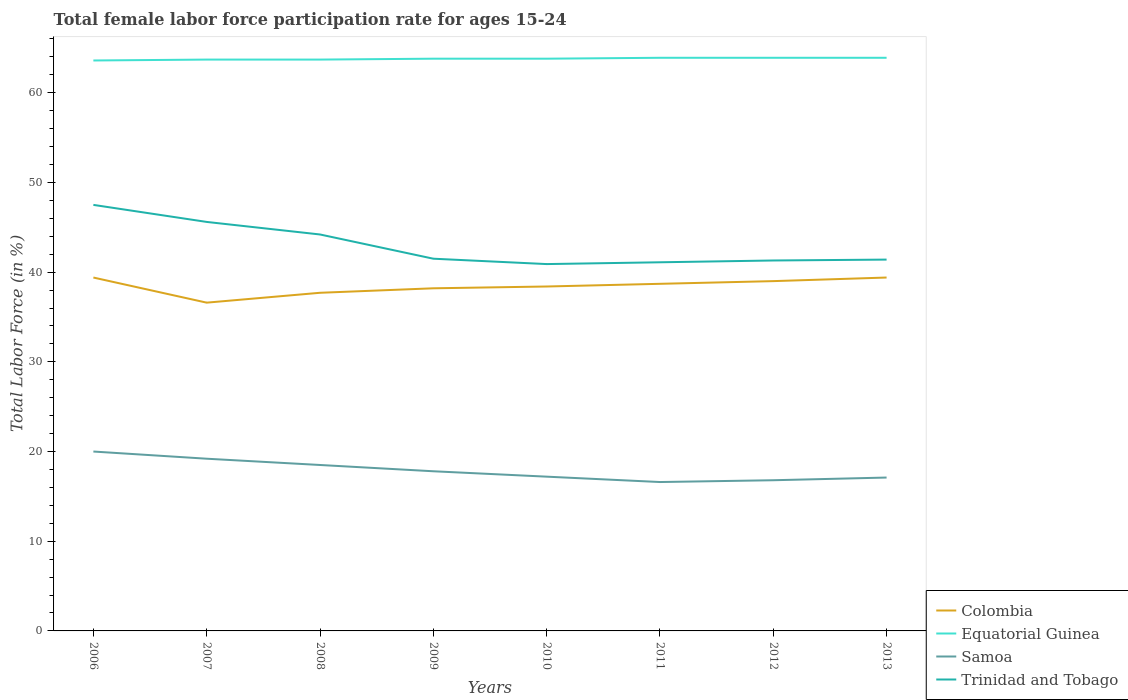How many different coloured lines are there?
Offer a terse response. 4. Across all years, what is the maximum female labor force participation rate in Colombia?
Give a very brief answer. 36.6. In which year was the female labor force participation rate in Equatorial Guinea maximum?
Ensure brevity in your answer.  2006. What is the total female labor force participation rate in Equatorial Guinea in the graph?
Offer a terse response. -0.1. What is the difference between the highest and the second highest female labor force participation rate in Colombia?
Ensure brevity in your answer.  2.8. How many lines are there?
Ensure brevity in your answer.  4. How many years are there in the graph?
Provide a succinct answer. 8. Are the values on the major ticks of Y-axis written in scientific E-notation?
Offer a terse response. No. What is the title of the graph?
Make the answer very short. Total female labor force participation rate for ages 15-24. What is the label or title of the X-axis?
Your response must be concise. Years. What is the label or title of the Y-axis?
Offer a terse response. Total Labor Force (in %). What is the Total Labor Force (in %) in Colombia in 2006?
Make the answer very short. 39.4. What is the Total Labor Force (in %) in Equatorial Guinea in 2006?
Your answer should be compact. 63.6. What is the Total Labor Force (in %) of Samoa in 2006?
Provide a short and direct response. 20. What is the Total Labor Force (in %) in Trinidad and Tobago in 2006?
Ensure brevity in your answer.  47.5. What is the Total Labor Force (in %) of Colombia in 2007?
Ensure brevity in your answer.  36.6. What is the Total Labor Force (in %) in Equatorial Guinea in 2007?
Make the answer very short. 63.7. What is the Total Labor Force (in %) of Samoa in 2007?
Offer a very short reply. 19.2. What is the Total Labor Force (in %) in Trinidad and Tobago in 2007?
Keep it short and to the point. 45.6. What is the Total Labor Force (in %) in Colombia in 2008?
Ensure brevity in your answer.  37.7. What is the Total Labor Force (in %) in Equatorial Guinea in 2008?
Provide a short and direct response. 63.7. What is the Total Labor Force (in %) in Trinidad and Tobago in 2008?
Ensure brevity in your answer.  44.2. What is the Total Labor Force (in %) of Colombia in 2009?
Ensure brevity in your answer.  38.2. What is the Total Labor Force (in %) in Equatorial Guinea in 2009?
Your answer should be compact. 63.8. What is the Total Labor Force (in %) in Samoa in 2009?
Your answer should be very brief. 17.8. What is the Total Labor Force (in %) of Trinidad and Tobago in 2009?
Offer a very short reply. 41.5. What is the Total Labor Force (in %) in Colombia in 2010?
Your answer should be very brief. 38.4. What is the Total Labor Force (in %) of Equatorial Guinea in 2010?
Offer a terse response. 63.8. What is the Total Labor Force (in %) of Samoa in 2010?
Provide a succinct answer. 17.2. What is the Total Labor Force (in %) in Trinidad and Tobago in 2010?
Offer a very short reply. 40.9. What is the Total Labor Force (in %) of Colombia in 2011?
Make the answer very short. 38.7. What is the Total Labor Force (in %) of Equatorial Guinea in 2011?
Offer a terse response. 63.9. What is the Total Labor Force (in %) in Samoa in 2011?
Provide a short and direct response. 16.6. What is the Total Labor Force (in %) of Trinidad and Tobago in 2011?
Ensure brevity in your answer.  41.1. What is the Total Labor Force (in %) of Equatorial Guinea in 2012?
Your answer should be compact. 63.9. What is the Total Labor Force (in %) in Samoa in 2012?
Your answer should be very brief. 16.8. What is the Total Labor Force (in %) in Trinidad and Tobago in 2012?
Your answer should be compact. 41.3. What is the Total Labor Force (in %) in Colombia in 2013?
Keep it short and to the point. 39.4. What is the Total Labor Force (in %) of Equatorial Guinea in 2013?
Give a very brief answer. 63.9. What is the Total Labor Force (in %) in Samoa in 2013?
Make the answer very short. 17.1. What is the Total Labor Force (in %) of Trinidad and Tobago in 2013?
Ensure brevity in your answer.  41.4. Across all years, what is the maximum Total Labor Force (in %) of Colombia?
Give a very brief answer. 39.4. Across all years, what is the maximum Total Labor Force (in %) in Equatorial Guinea?
Offer a very short reply. 63.9. Across all years, what is the maximum Total Labor Force (in %) of Samoa?
Give a very brief answer. 20. Across all years, what is the maximum Total Labor Force (in %) of Trinidad and Tobago?
Offer a terse response. 47.5. Across all years, what is the minimum Total Labor Force (in %) in Colombia?
Your response must be concise. 36.6. Across all years, what is the minimum Total Labor Force (in %) of Equatorial Guinea?
Give a very brief answer. 63.6. Across all years, what is the minimum Total Labor Force (in %) in Samoa?
Keep it short and to the point. 16.6. Across all years, what is the minimum Total Labor Force (in %) of Trinidad and Tobago?
Offer a terse response. 40.9. What is the total Total Labor Force (in %) in Colombia in the graph?
Your answer should be compact. 307.4. What is the total Total Labor Force (in %) in Equatorial Guinea in the graph?
Keep it short and to the point. 510.3. What is the total Total Labor Force (in %) in Samoa in the graph?
Ensure brevity in your answer.  143.2. What is the total Total Labor Force (in %) in Trinidad and Tobago in the graph?
Make the answer very short. 343.5. What is the difference between the Total Labor Force (in %) of Colombia in 2006 and that in 2007?
Make the answer very short. 2.8. What is the difference between the Total Labor Force (in %) of Trinidad and Tobago in 2006 and that in 2007?
Give a very brief answer. 1.9. What is the difference between the Total Labor Force (in %) of Colombia in 2006 and that in 2008?
Make the answer very short. 1.7. What is the difference between the Total Labor Force (in %) of Samoa in 2006 and that in 2008?
Give a very brief answer. 1.5. What is the difference between the Total Labor Force (in %) of Colombia in 2006 and that in 2009?
Provide a short and direct response. 1.2. What is the difference between the Total Labor Force (in %) in Equatorial Guinea in 2006 and that in 2009?
Offer a terse response. -0.2. What is the difference between the Total Labor Force (in %) of Colombia in 2006 and that in 2010?
Make the answer very short. 1. What is the difference between the Total Labor Force (in %) of Equatorial Guinea in 2006 and that in 2010?
Offer a very short reply. -0.2. What is the difference between the Total Labor Force (in %) of Samoa in 2006 and that in 2010?
Give a very brief answer. 2.8. What is the difference between the Total Labor Force (in %) in Trinidad and Tobago in 2006 and that in 2010?
Give a very brief answer. 6.6. What is the difference between the Total Labor Force (in %) in Colombia in 2006 and that in 2011?
Offer a terse response. 0.7. What is the difference between the Total Labor Force (in %) in Equatorial Guinea in 2006 and that in 2011?
Provide a short and direct response. -0.3. What is the difference between the Total Labor Force (in %) of Colombia in 2006 and that in 2012?
Provide a short and direct response. 0.4. What is the difference between the Total Labor Force (in %) of Samoa in 2006 and that in 2012?
Your answer should be very brief. 3.2. What is the difference between the Total Labor Force (in %) of Trinidad and Tobago in 2006 and that in 2012?
Your answer should be compact. 6.2. What is the difference between the Total Labor Force (in %) of Equatorial Guinea in 2006 and that in 2013?
Your answer should be very brief. -0.3. What is the difference between the Total Labor Force (in %) of Colombia in 2007 and that in 2008?
Your answer should be very brief. -1.1. What is the difference between the Total Labor Force (in %) in Trinidad and Tobago in 2007 and that in 2008?
Offer a very short reply. 1.4. What is the difference between the Total Labor Force (in %) of Colombia in 2007 and that in 2009?
Your response must be concise. -1.6. What is the difference between the Total Labor Force (in %) of Samoa in 2007 and that in 2009?
Provide a succinct answer. 1.4. What is the difference between the Total Labor Force (in %) in Colombia in 2007 and that in 2010?
Ensure brevity in your answer.  -1.8. What is the difference between the Total Labor Force (in %) in Equatorial Guinea in 2007 and that in 2010?
Keep it short and to the point. -0.1. What is the difference between the Total Labor Force (in %) in Trinidad and Tobago in 2007 and that in 2011?
Your answer should be compact. 4.5. What is the difference between the Total Labor Force (in %) in Colombia in 2007 and that in 2012?
Ensure brevity in your answer.  -2.4. What is the difference between the Total Labor Force (in %) in Equatorial Guinea in 2007 and that in 2012?
Your answer should be very brief. -0.2. What is the difference between the Total Labor Force (in %) of Samoa in 2007 and that in 2012?
Keep it short and to the point. 2.4. What is the difference between the Total Labor Force (in %) of Trinidad and Tobago in 2007 and that in 2012?
Provide a short and direct response. 4.3. What is the difference between the Total Labor Force (in %) in Colombia in 2007 and that in 2013?
Keep it short and to the point. -2.8. What is the difference between the Total Labor Force (in %) in Trinidad and Tobago in 2007 and that in 2013?
Your response must be concise. 4.2. What is the difference between the Total Labor Force (in %) in Equatorial Guinea in 2008 and that in 2009?
Your response must be concise. -0.1. What is the difference between the Total Labor Force (in %) of Equatorial Guinea in 2008 and that in 2010?
Your answer should be compact. -0.1. What is the difference between the Total Labor Force (in %) of Samoa in 2008 and that in 2010?
Your response must be concise. 1.3. What is the difference between the Total Labor Force (in %) in Trinidad and Tobago in 2008 and that in 2010?
Provide a succinct answer. 3.3. What is the difference between the Total Labor Force (in %) of Trinidad and Tobago in 2008 and that in 2011?
Ensure brevity in your answer.  3.1. What is the difference between the Total Labor Force (in %) of Equatorial Guinea in 2008 and that in 2012?
Offer a terse response. -0.2. What is the difference between the Total Labor Force (in %) in Trinidad and Tobago in 2008 and that in 2012?
Provide a succinct answer. 2.9. What is the difference between the Total Labor Force (in %) in Colombia in 2008 and that in 2013?
Offer a very short reply. -1.7. What is the difference between the Total Labor Force (in %) in Equatorial Guinea in 2009 and that in 2010?
Ensure brevity in your answer.  0. What is the difference between the Total Labor Force (in %) of Colombia in 2009 and that in 2011?
Give a very brief answer. -0.5. What is the difference between the Total Labor Force (in %) of Equatorial Guinea in 2009 and that in 2011?
Provide a short and direct response. -0.1. What is the difference between the Total Labor Force (in %) in Equatorial Guinea in 2009 and that in 2012?
Keep it short and to the point. -0.1. What is the difference between the Total Labor Force (in %) of Samoa in 2009 and that in 2012?
Your answer should be compact. 1. What is the difference between the Total Labor Force (in %) in Trinidad and Tobago in 2009 and that in 2012?
Provide a succinct answer. 0.2. What is the difference between the Total Labor Force (in %) of Equatorial Guinea in 2009 and that in 2013?
Your response must be concise. -0.1. What is the difference between the Total Labor Force (in %) in Trinidad and Tobago in 2009 and that in 2013?
Your answer should be compact. 0.1. What is the difference between the Total Labor Force (in %) in Colombia in 2010 and that in 2011?
Your answer should be compact. -0.3. What is the difference between the Total Labor Force (in %) of Trinidad and Tobago in 2010 and that in 2011?
Make the answer very short. -0.2. What is the difference between the Total Labor Force (in %) of Colombia in 2010 and that in 2012?
Offer a very short reply. -0.6. What is the difference between the Total Labor Force (in %) of Equatorial Guinea in 2010 and that in 2012?
Offer a very short reply. -0.1. What is the difference between the Total Labor Force (in %) of Trinidad and Tobago in 2010 and that in 2012?
Give a very brief answer. -0.4. What is the difference between the Total Labor Force (in %) in Equatorial Guinea in 2010 and that in 2013?
Your answer should be compact. -0.1. What is the difference between the Total Labor Force (in %) in Samoa in 2010 and that in 2013?
Keep it short and to the point. 0.1. What is the difference between the Total Labor Force (in %) in Trinidad and Tobago in 2010 and that in 2013?
Your answer should be compact. -0.5. What is the difference between the Total Labor Force (in %) in Equatorial Guinea in 2011 and that in 2012?
Give a very brief answer. 0. What is the difference between the Total Labor Force (in %) of Samoa in 2011 and that in 2012?
Your answer should be compact. -0.2. What is the difference between the Total Labor Force (in %) of Trinidad and Tobago in 2011 and that in 2012?
Make the answer very short. -0.2. What is the difference between the Total Labor Force (in %) in Colombia in 2011 and that in 2013?
Ensure brevity in your answer.  -0.7. What is the difference between the Total Labor Force (in %) in Samoa in 2011 and that in 2013?
Your response must be concise. -0.5. What is the difference between the Total Labor Force (in %) of Trinidad and Tobago in 2011 and that in 2013?
Your answer should be compact. -0.3. What is the difference between the Total Labor Force (in %) of Colombia in 2012 and that in 2013?
Ensure brevity in your answer.  -0.4. What is the difference between the Total Labor Force (in %) in Equatorial Guinea in 2012 and that in 2013?
Give a very brief answer. 0. What is the difference between the Total Labor Force (in %) of Samoa in 2012 and that in 2013?
Give a very brief answer. -0.3. What is the difference between the Total Labor Force (in %) in Trinidad and Tobago in 2012 and that in 2013?
Make the answer very short. -0.1. What is the difference between the Total Labor Force (in %) in Colombia in 2006 and the Total Labor Force (in %) in Equatorial Guinea in 2007?
Keep it short and to the point. -24.3. What is the difference between the Total Labor Force (in %) of Colombia in 2006 and the Total Labor Force (in %) of Samoa in 2007?
Ensure brevity in your answer.  20.2. What is the difference between the Total Labor Force (in %) of Equatorial Guinea in 2006 and the Total Labor Force (in %) of Samoa in 2007?
Offer a terse response. 44.4. What is the difference between the Total Labor Force (in %) of Equatorial Guinea in 2006 and the Total Labor Force (in %) of Trinidad and Tobago in 2007?
Offer a terse response. 18. What is the difference between the Total Labor Force (in %) in Samoa in 2006 and the Total Labor Force (in %) in Trinidad and Tobago in 2007?
Ensure brevity in your answer.  -25.6. What is the difference between the Total Labor Force (in %) in Colombia in 2006 and the Total Labor Force (in %) in Equatorial Guinea in 2008?
Give a very brief answer. -24.3. What is the difference between the Total Labor Force (in %) in Colombia in 2006 and the Total Labor Force (in %) in Samoa in 2008?
Keep it short and to the point. 20.9. What is the difference between the Total Labor Force (in %) in Colombia in 2006 and the Total Labor Force (in %) in Trinidad and Tobago in 2008?
Your answer should be compact. -4.8. What is the difference between the Total Labor Force (in %) of Equatorial Guinea in 2006 and the Total Labor Force (in %) of Samoa in 2008?
Offer a very short reply. 45.1. What is the difference between the Total Labor Force (in %) in Equatorial Guinea in 2006 and the Total Labor Force (in %) in Trinidad and Tobago in 2008?
Keep it short and to the point. 19.4. What is the difference between the Total Labor Force (in %) in Samoa in 2006 and the Total Labor Force (in %) in Trinidad and Tobago in 2008?
Provide a short and direct response. -24.2. What is the difference between the Total Labor Force (in %) of Colombia in 2006 and the Total Labor Force (in %) of Equatorial Guinea in 2009?
Your answer should be very brief. -24.4. What is the difference between the Total Labor Force (in %) of Colombia in 2006 and the Total Labor Force (in %) of Samoa in 2009?
Offer a very short reply. 21.6. What is the difference between the Total Labor Force (in %) of Colombia in 2006 and the Total Labor Force (in %) of Trinidad and Tobago in 2009?
Provide a succinct answer. -2.1. What is the difference between the Total Labor Force (in %) of Equatorial Guinea in 2006 and the Total Labor Force (in %) of Samoa in 2009?
Provide a short and direct response. 45.8. What is the difference between the Total Labor Force (in %) of Equatorial Guinea in 2006 and the Total Labor Force (in %) of Trinidad and Tobago in 2009?
Provide a short and direct response. 22.1. What is the difference between the Total Labor Force (in %) of Samoa in 2006 and the Total Labor Force (in %) of Trinidad and Tobago in 2009?
Your answer should be very brief. -21.5. What is the difference between the Total Labor Force (in %) of Colombia in 2006 and the Total Labor Force (in %) of Equatorial Guinea in 2010?
Ensure brevity in your answer.  -24.4. What is the difference between the Total Labor Force (in %) in Equatorial Guinea in 2006 and the Total Labor Force (in %) in Samoa in 2010?
Keep it short and to the point. 46.4. What is the difference between the Total Labor Force (in %) of Equatorial Guinea in 2006 and the Total Labor Force (in %) of Trinidad and Tobago in 2010?
Keep it short and to the point. 22.7. What is the difference between the Total Labor Force (in %) in Samoa in 2006 and the Total Labor Force (in %) in Trinidad and Tobago in 2010?
Offer a very short reply. -20.9. What is the difference between the Total Labor Force (in %) of Colombia in 2006 and the Total Labor Force (in %) of Equatorial Guinea in 2011?
Provide a short and direct response. -24.5. What is the difference between the Total Labor Force (in %) in Colombia in 2006 and the Total Labor Force (in %) in Samoa in 2011?
Offer a very short reply. 22.8. What is the difference between the Total Labor Force (in %) of Colombia in 2006 and the Total Labor Force (in %) of Trinidad and Tobago in 2011?
Offer a terse response. -1.7. What is the difference between the Total Labor Force (in %) of Equatorial Guinea in 2006 and the Total Labor Force (in %) of Samoa in 2011?
Ensure brevity in your answer.  47. What is the difference between the Total Labor Force (in %) in Samoa in 2006 and the Total Labor Force (in %) in Trinidad and Tobago in 2011?
Provide a short and direct response. -21.1. What is the difference between the Total Labor Force (in %) in Colombia in 2006 and the Total Labor Force (in %) in Equatorial Guinea in 2012?
Give a very brief answer. -24.5. What is the difference between the Total Labor Force (in %) of Colombia in 2006 and the Total Labor Force (in %) of Samoa in 2012?
Keep it short and to the point. 22.6. What is the difference between the Total Labor Force (in %) in Equatorial Guinea in 2006 and the Total Labor Force (in %) in Samoa in 2012?
Provide a short and direct response. 46.8. What is the difference between the Total Labor Force (in %) of Equatorial Guinea in 2006 and the Total Labor Force (in %) of Trinidad and Tobago in 2012?
Your response must be concise. 22.3. What is the difference between the Total Labor Force (in %) of Samoa in 2006 and the Total Labor Force (in %) of Trinidad and Tobago in 2012?
Your answer should be compact. -21.3. What is the difference between the Total Labor Force (in %) in Colombia in 2006 and the Total Labor Force (in %) in Equatorial Guinea in 2013?
Give a very brief answer. -24.5. What is the difference between the Total Labor Force (in %) in Colombia in 2006 and the Total Labor Force (in %) in Samoa in 2013?
Make the answer very short. 22.3. What is the difference between the Total Labor Force (in %) in Colombia in 2006 and the Total Labor Force (in %) in Trinidad and Tobago in 2013?
Your answer should be very brief. -2. What is the difference between the Total Labor Force (in %) in Equatorial Guinea in 2006 and the Total Labor Force (in %) in Samoa in 2013?
Your answer should be very brief. 46.5. What is the difference between the Total Labor Force (in %) in Equatorial Guinea in 2006 and the Total Labor Force (in %) in Trinidad and Tobago in 2013?
Offer a very short reply. 22.2. What is the difference between the Total Labor Force (in %) in Samoa in 2006 and the Total Labor Force (in %) in Trinidad and Tobago in 2013?
Offer a terse response. -21.4. What is the difference between the Total Labor Force (in %) in Colombia in 2007 and the Total Labor Force (in %) in Equatorial Guinea in 2008?
Offer a very short reply. -27.1. What is the difference between the Total Labor Force (in %) of Colombia in 2007 and the Total Labor Force (in %) of Samoa in 2008?
Make the answer very short. 18.1. What is the difference between the Total Labor Force (in %) of Colombia in 2007 and the Total Labor Force (in %) of Trinidad and Tobago in 2008?
Your answer should be very brief. -7.6. What is the difference between the Total Labor Force (in %) of Equatorial Guinea in 2007 and the Total Labor Force (in %) of Samoa in 2008?
Keep it short and to the point. 45.2. What is the difference between the Total Labor Force (in %) of Equatorial Guinea in 2007 and the Total Labor Force (in %) of Trinidad and Tobago in 2008?
Provide a succinct answer. 19.5. What is the difference between the Total Labor Force (in %) of Colombia in 2007 and the Total Labor Force (in %) of Equatorial Guinea in 2009?
Offer a terse response. -27.2. What is the difference between the Total Labor Force (in %) in Equatorial Guinea in 2007 and the Total Labor Force (in %) in Samoa in 2009?
Ensure brevity in your answer.  45.9. What is the difference between the Total Labor Force (in %) of Samoa in 2007 and the Total Labor Force (in %) of Trinidad and Tobago in 2009?
Your answer should be very brief. -22.3. What is the difference between the Total Labor Force (in %) in Colombia in 2007 and the Total Labor Force (in %) in Equatorial Guinea in 2010?
Your response must be concise. -27.2. What is the difference between the Total Labor Force (in %) of Equatorial Guinea in 2007 and the Total Labor Force (in %) of Samoa in 2010?
Your response must be concise. 46.5. What is the difference between the Total Labor Force (in %) in Equatorial Guinea in 2007 and the Total Labor Force (in %) in Trinidad and Tobago in 2010?
Offer a terse response. 22.8. What is the difference between the Total Labor Force (in %) in Samoa in 2007 and the Total Labor Force (in %) in Trinidad and Tobago in 2010?
Your answer should be very brief. -21.7. What is the difference between the Total Labor Force (in %) in Colombia in 2007 and the Total Labor Force (in %) in Equatorial Guinea in 2011?
Offer a terse response. -27.3. What is the difference between the Total Labor Force (in %) in Colombia in 2007 and the Total Labor Force (in %) in Samoa in 2011?
Offer a very short reply. 20. What is the difference between the Total Labor Force (in %) in Colombia in 2007 and the Total Labor Force (in %) in Trinidad and Tobago in 2011?
Offer a terse response. -4.5. What is the difference between the Total Labor Force (in %) of Equatorial Guinea in 2007 and the Total Labor Force (in %) of Samoa in 2011?
Make the answer very short. 47.1. What is the difference between the Total Labor Force (in %) in Equatorial Guinea in 2007 and the Total Labor Force (in %) in Trinidad and Tobago in 2011?
Your answer should be very brief. 22.6. What is the difference between the Total Labor Force (in %) of Samoa in 2007 and the Total Labor Force (in %) of Trinidad and Tobago in 2011?
Offer a very short reply. -21.9. What is the difference between the Total Labor Force (in %) in Colombia in 2007 and the Total Labor Force (in %) in Equatorial Guinea in 2012?
Provide a succinct answer. -27.3. What is the difference between the Total Labor Force (in %) of Colombia in 2007 and the Total Labor Force (in %) of Samoa in 2012?
Your answer should be compact. 19.8. What is the difference between the Total Labor Force (in %) of Equatorial Guinea in 2007 and the Total Labor Force (in %) of Samoa in 2012?
Your answer should be very brief. 46.9. What is the difference between the Total Labor Force (in %) in Equatorial Guinea in 2007 and the Total Labor Force (in %) in Trinidad and Tobago in 2012?
Your answer should be compact. 22.4. What is the difference between the Total Labor Force (in %) of Samoa in 2007 and the Total Labor Force (in %) of Trinidad and Tobago in 2012?
Your answer should be very brief. -22.1. What is the difference between the Total Labor Force (in %) of Colombia in 2007 and the Total Labor Force (in %) of Equatorial Guinea in 2013?
Offer a terse response. -27.3. What is the difference between the Total Labor Force (in %) in Colombia in 2007 and the Total Labor Force (in %) in Trinidad and Tobago in 2013?
Offer a very short reply. -4.8. What is the difference between the Total Labor Force (in %) of Equatorial Guinea in 2007 and the Total Labor Force (in %) of Samoa in 2013?
Make the answer very short. 46.6. What is the difference between the Total Labor Force (in %) in Equatorial Guinea in 2007 and the Total Labor Force (in %) in Trinidad and Tobago in 2013?
Ensure brevity in your answer.  22.3. What is the difference between the Total Labor Force (in %) in Samoa in 2007 and the Total Labor Force (in %) in Trinidad and Tobago in 2013?
Keep it short and to the point. -22.2. What is the difference between the Total Labor Force (in %) of Colombia in 2008 and the Total Labor Force (in %) of Equatorial Guinea in 2009?
Make the answer very short. -26.1. What is the difference between the Total Labor Force (in %) of Equatorial Guinea in 2008 and the Total Labor Force (in %) of Samoa in 2009?
Your answer should be compact. 45.9. What is the difference between the Total Labor Force (in %) of Equatorial Guinea in 2008 and the Total Labor Force (in %) of Trinidad and Tobago in 2009?
Offer a terse response. 22.2. What is the difference between the Total Labor Force (in %) of Samoa in 2008 and the Total Labor Force (in %) of Trinidad and Tobago in 2009?
Offer a terse response. -23. What is the difference between the Total Labor Force (in %) in Colombia in 2008 and the Total Labor Force (in %) in Equatorial Guinea in 2010?
Offer a terse response. -26.1. What is the difference between the Total Labor Force (in %) in Colombia in 2008 and the Total Labor Force (in %) in Samoa in 2010?
Your answer should be compact. 20.5. What is the difference between the Total Labor Force (in %) in Colombia in 2008 and the Total Labor Force (in %) in Trinidad and Tobago in 2010?
Provide a succinct answer. -3.2. What is the difference between the Total Labor Force (in %) of Equatorial Guinea in 2008 and the Total Labor Force (in %) of Samoa in 2010?
Offer a terse response. 46.5. What is the difference between the Total Labor Force (in %) of Equatorial Guinea in 2008 and the Total Labor Force (in %) of Trinidad and Tobago in 2010?
Offer a very short reply. 22.8. What is the difference between the Total Labor Force (in %) in Samoa in 2008 and the Total Labor Force (in %) in Trinidad and Tobago in 2010?
Your answer should be very brief. -22.4. What is the difference between the Total Labor Force (in %) of Colombia in 2008 and the Total Labor Force (in %) of Equatorial Guinea in 2011?
Ensure brevity in your answer.  -26.2. What is the difference between the Total Labor Force (in %) of Colombia in 2008 and the Total Labor Force (in %) of Samoa in 2011?
Your answer should be compact. 21.1. What is the difference between the Total Labor Force (in %) of Equatorial Guinea in 2008 and the Total Labor Force (in %) of Samoa in 2011?
Ensure brevity in your answer.  47.1. What is the difference between the Total Labor Force (in %) of Equatorial Guinea in 2008 and the Total Labor Force (in %) of Trinidad and Tobago in 2011?
Provide a succinct answer. 22.6. What is the difference between the Total Labor Force (in %) of Samoa in 2008 and the Total Labor Force (in %) of Trinidad and Tobago in 2011?
Your response must be concise. -22.6. What is the difference between the Total Labor Force (in %) of Colombia in 2008 and the Total Labor Force (in %) of Equatorial Guinea in 2012?
Your answer should be compact. -26.2. What is the difference between the Total Labor Force (in %) in Colombia in 2008 and the Total Labor Force (in %) in Samoa in 2012?
Keep it short and to the point. 20.9. What is the difference between the Total Labor Force (in %) of Equatorial Guinea in 2008 and the Total Labor Force (in %) of Samoa in 2012?
Offer a terse response. 46.9. What is the difference between the Total Labor Force (in %) of Equatorial Guinea in 2008 and the Total Labor Force (in %) of Trinidad and Tobago in 2012?
Your answer should be compact. 22.4. What is the difference between the Total Labor Force (in %) in Samoa in 2008 and the Total Labor Force (in %) in Trinidad and Tobago in 2012?
Your answer should be very brief. -22.8. What is the difference between the Total Labor Force (in %) in Colombia in 2008 and the Total Labor Force (in %) in Equatorial Guinea in 2013?
Offer a terse response. -26.2. What is the difference between the Total Labor Force (in %) of Colombia in 2008 and the Total Labor Force (in %) of Samoa in 2013?
Provide a short and direct response. 20.6. What is the difference between the Total Labor Force (in %) in Colombia in 2008 and the Total Labor Force (in %) in Trinidad and Tobago in 2013?
Your answer should be compact. -3.7. What is the difference between the Total Labor Force (in %) in Equatorial Guinea in 2008 and the Total Labor Force (in %) in Samoa in 2013?
Your answer should be compact. 46.6. What is the difference between the Total Labor Force (in %) of Equatorial Guinea in 2008 and the Total Labor Force (in %) of Trinidad and Tobago in 2013?
Your answer should be compact. 22.3. What is the difference between the Total Labor Force (in %) in Samoa in 2008 and the Total Labor Force (in %) in Trinidad and Tobago in 2013?
Provide a short and direct response. -22.9. What is the difference between the Total Labor Force (in %) of Colombia in 2009 and the Total Labor Force (in %) of Equatorial Guinea in 2010?
Provide a succinct answer. -25.6. What is the difference between the Total Labor Force (in %) in Colombia in 2009 and the Total Labor Force (in %) in Samoa in 2010?
Your answer should be compact. 21. What is the difference between the Total Labor Force (in %) of Equatorial Guinea in 2009 and the Total Labor Force (in %) of Samoa in 2010?
Offer a terse response. 46.6. What is the difference between the Total Labor Force (in %) in Equatorial Guinea in 2009 and the Total Labor Force (in %) in Trinidad and Tobago in 2010?
Offer a terse response. 22.9. What is the difference between the Total Labor Force (in %) of Samoa in 2009 and the Total Labor Force (in %) of Trinidad and Tobago in 2010?
Your answer should be very brief. -23.1. What is the difference between the Total Labor Force (in %) of Colombia in 2009 and the Total Labor Force (in %) of Equatorial Guinea in 2011?
Offer a terse response. -25.7. What is the difference between the Total Labor Force (in %) of Colombia in 2009 and the Total Labor Force (in %) of Samoa in 2011?
Ensure brevity in your answer.  21.6. What is the difference between the Total Labor Force (in %) of Equatorial Guinea in 2009 and the Total Labor Force (in %) of Samoa in 2011?
Offer a very short reply. 47.2. What is the difference between the Total Labor Force (in %) of Equatorial Guinea in 2009 and the Total Labor Force (in %) of Trinidad and Tobago in 2011?
Your answer should be very brief. 22.7. What is the difference between the Total Labor Force (in %) in Samoa in 2009 and the Total Labor Force (in %) in Trinidad and Tobago in 2011?
Give a very brief answer. -23.3. What is the difference between the Total Labor Force (in %) of Colombia in 2009 and the Total Labor Force (in %) of Equatorial Guinea in 2012?
Your answer should be compact. -25.7. What is the difference between the Total Labor Force (in %) in Colombia in 2009 and the Total Labor Force (in %) in Samoa in 2012?
Your answer should be compact. 21.4. What is the difference between the Total Labor Force (in %) of Equatorial Guinea in 2009 and the Total Labor Force (in %) of Samoa in 2012?
Your answer should be compact. 47. What is the difference between the Total Labor Force (in %) in Samoa in 2009 and the Total Labor Force (in %) in Trinidad and Tobago in 2012?
Keep it short and to the point. -23.5. What is the difference between the Total Labor Force (in %) of Colombia in 2009 and the Total Labor Force (in %) of Equatorial Guinea in 2013?
Make the answer very short. -25.7. What is the difference between the Total Labor Force (in %) of Colombia in 2009 and the Total Labor Force (in %) of Samoa in 2013?
Ensure brevity in your answer.  21.1. What is the difference between the Total Labor Force (in %) of Equatorial Guinea in 2009 and the Total Labor Force (in %) of Samoa in 2013?
Provide a succinct answer. 46.7. What is the difference between the Total Labor Force (in %) of Equatorial Guinea in 2009 and the Total Labor Force (in %) of Trinidad and Tobago in 2013?
Your response must be concise. 22.4. What is the difference between the Total Labor Force (in %) of Samoa in 2009 and the Total Labor Force (in %) of Trinidad and Tobago in 2013?
Offer a terse response. -23.6. What is the difference between the Total Labor Force (in %) in Colombia in 2010 and the Total Labor Force (in %) in Equatorial Guinea in 2011?
Offer a very short reply. -25.5. What is the difference between the Total Labor Force (in %) of Colombia in 2010 and the Total Labor Force (in %) of Samoa in 2011?
Make the answer very short. 21.8. What is the difference between the Total Labor Force (in %) of Colombia in 2010 and the Total Labor Force (in %) of Trinidad and Tobago in 2011?
Ensure brevity in your answer.  -2.7. What is the difference between the Total Labor Force (in %) of Equatorial Guinea in 2010 and the Total Labor Force (in %) of Samoa in 2011?
Offer a terse response. 47.2. What is the difference between the Total Labor Force (in %) of Equatorial Guinea in 2010 and the Total Labor Force (in %) of Trinidad and Tobago in 2011?
Provide a short and direct response. 22.7. What is the difference between the Total Labor Force (in %) in Samoa in 2010 and the Total Labor Force (in %) in Trinidad and Tobago in 2011?
Provide a succinct answer. -23.9. What is the difference between the Total Labor Force (in %) in Colombia in 2010 and the Total Labor Force (in %) in Equatorial Guinea in 2012?
Your answer should be compact. -25.5. What is the difference between the Total Labor Force (in %) of Colombia in 2010 and the Total Labor Force (in %) of Samoa in 2012?
Keep it short and to the point. 21.6. What is the difference between the Total Labor Force (in %) in Colombia in 2010 and the Total Labor Force (in %) in Trinidad and Tobago in 2012?
Your response must be concise. -2.9. What is the difference between the Total Labor Force (in %) in Samoa in 2010 and the Total Labor Force (in %) in Trinidad and Tobago in 2012?
Give a very brief answer. -24.1. What is the difference between the Total Labor Force (in %) in Colombia in 2010 and the Total Labor Force (in %) in Equatorial Guinea in 2013?
Provide a short and direct response. -25.5. What is the difference between the Total Labor Force (in %) in Colombia in 2010 and the Total Labor Force (in %) in Samoa in 2013?
Keep it short and to the point. 21.3. What is the difference between the Total Labor Force (in %) in Equatorial Guinea in 2010 and the Total Labor Force (in %) in Samoa in 2013?
Keep it short and to the point. 46.7. What is the difference between the Total Labor Force (in %) in Equatorial Guinea in 2010 and the Total Labor Force (in %) in Trinidad and Tobago in 2013?
Offer a terse response. 22.4. What is the difference between the Total Labor Force (in %) of Samoa in 2010 and the Total Labor Force (in %) of Trinidad and Tobago in 2013?
Ensure brevity in your answer.  -24.2. What is the difference between the Total Labor Force (in %) of Colombia in 2011 and the Total Labor Force (in %) of Equatorial Guinea in 2012?
Make the answer very short. -25.2. What is the difference between the Total Labor Force (in %) of Colombia in 2011 and the Total Labor Force (in %) of Samoa in 2012?
Make the answer very short. 21.9. What is the difference between the Total Labor Force (in %) in Colombia in 2011 and the Total Labor Force (in %) in Trinidad and Tobago in 2012?
Your answer should be very brief. -2.6. What is the difference between the Total Labor Force (in %) of Equatorial Guinea in 2011 and the Total Labor Force (in %) of Samoa in 2012?
Keep it short and to the point. 47.1. What is the difference between the Total Labor Force (in %) of Equatorial Guinea in 2011 and the Total Labor Force (in %) of Trinidad and Tobago in 2012?
Offer a very short reply. 22.6. What is the difference between the Total Labor Force (in %) in Samoa in 2011 and the Total Labor Force (in %) in Trinidad and Tobago in 2012?
Offer a terse response. -24.7. What is the difference between the Total Labor Force (in %) of Colombia in 2011 and the Total Labor Force (in %) of Equatorial Guinea in 2013?
Ensure brevity in your answer.  -25.2. What is the difference between the Total Labor Force (in %) in Colombia in 2011 and the Total Labor Force (in %) in Samoa in 2013?
Your response must be concise. 21.6. What is the difference between the Total Labor Force (in %) in Colombia in 2011 and the Total Labor Force (in %) in Trinidad and Tobago in 2013?
Provide a succinct answer. -2.7. What is the difference between the Total Labor Force (in %) in Equatorial Guinea in 2011 and the Total Labor Force (in %) in Samoa in 2013?
Provide a succinct answer. 46.8. What is the difference between the Total Labor Force (in %) of Samoa in 2011 and the Total Labor Force (in %) of Trinidad and Tobago in 2013?
Offer a terse response. -24.8. What is the difference between the Total Labor Force (in %) in Colombia in 2012 and the Total Labor Force (in %) in Equatorial Guinea in 2013?
Your response must be concise. -24.9. What is the difference between the Total Labor Force (in %) of Colombia in 2012 and the Total Labor Force (in %) of Samoa in 2013?
Offer a terse response. 21.9. What is the difference between the Total Labor Force (in %) of Colombia in 2012 and the Total Labor Force (in %) of Trinidad and Tobago in 2013?
Provide a succinct answer. -2.4. What is the difference between the Total Labor Force (in %) of Equatorial Guinea in 2012 and the Total Labor Force (in %) of Samoa in 2013?
Your response must be concise. 46.8. What is the difference between the Total Labor Force (in %) in Equatorial Guinea in 2012 and the Total Labor Force (in %) in Trinidad and Tobago in 2013?
Make the answer very short. 22.5. What is the difference between the Total Labor Force (in %) of Samoa in 2012 and the Total Labor Force (in %) of Trinidad and Tobago in 2013?
Offer a very short reply. -24.6. What is the average Total Labor Force (in %) in Colombia per year?
Ensure brevity in your answer.  38.42. What is the average Total Labor Force (in %) of Equatorial Guinea per year?
Provide a succinct answer. 63.79. What is the average Total Labor Force (in %) in Trinidad and Tobago per year?
Offer a very short reply. 42.94. In the year 2006, what is the difference between the Total Labor Force (in %) of Colombia and Total Labor Force (in %) of Equatorial Guinea?
Offer a terse response. -24.2. In the year 2006, what is the difference between the Total Labor Force (in %) in Equatorial Guinea and Total Labor Force (in %) in Samoa?
Offer a very short reply. 43.6. In the year 2006, what is the difference between the Total Labor Force (in %) of Samoa and Total Labor Force (in %) of Trinidad and Tobago?
Offer a very short reply. -27.5. In the year 2007, what is the difference between the Total Labor Force (in %) in Colombia and Total Labor Force (in %) in Equatorial Guinea?
Your answer should be very brief. -27.1. In the year 2007, what is the difference between the Total Labor Force (in %) in Colombia and Total Labor Force (in %) in Samoa?
Make the answer very short. 17.4. In the year 2007, what is the difference between the Total Labor Force (in %) in Equatorial Guinea and Total Labor Force (in %) in Samoa?
Ensure brevity in your answer.  44.5. In the year 2007, what is the difference between the Total Labor Force (in %) of Equatorial Guinea and Total Labor Force (in %) of Trinidad and Tobago?
Offer a terse response. 18.1. In the year 2007, what is the difference between the Total Labor Force (in %) in Samoa and Total Labor Force (in %) in Trinidad and Tobago?
Make the answer very short. -26.4. In the year 2008, what is the difference between the Total Labor Force (in %) in Colombia and Total Labor Force (in %) in Equatorial Guinea?
Make the answer very short. -26. In the year 2008, what is the difference between the Total Labor Force (in %) in Equatorial Guinea and Total Labor Force (in %) in Samoa?
Give a very brief answer. 45.2. In the year 2008, what is the difference between the Total Labor Force (in %) in Samoa and Total Labor Force (in %) in Trinidad and Tobago?
Your answer should be very brief. -25.7. In the year 2009, what is the difference between the Total Labor Force (in %) of Colombia and Total Labor Force (in %) of Equatorial Guinea?
Offer a very short reply. -25.6. In the year 2009, what is the difference between the Total Labor Force (in %) of Colombia and Total Labor Force (in %) of Samoa?
Your answer should be very brief. 20.4. In the year 2009, what is the difference between the Total Labor Force (in %) of Equatorial Guinea and Total Labor Force (in %) of Samoa?
Offer a terse response. 46. In the year 2009, what is the difference between the Total Labor Force (in %) of Equatorial Guinea and Total Labor Force (in %) of Trinidad and Tobago?
Offer a very short reply. 22.3. In the year 2009, what is the difference between the Total Labor Force (in %) of Samoa and Total Labor Force (in %) of Trinidad and Tobago?
Your answer should be compact. -23.7. In the year 2010, what is the difference between the Total Labor Force (in %) of Colombia and Total Labor Force (in %) of Equatorial Guinea?
Your answer should be compact. -25.4. In the year 2010, what is the difference between the Total Labor Force (in %) in Colombia and Total Labor Force (in %) in Samoa?
Your answer should be compact. 21.2. In the year 2010, what is the difference between the Total Labor Force (in %) of Equatorial Guinea and Total Labor Force (in %) of Samoa?
Offer a terse response. 46.6. In the year 2010, what is the difference between the Total Labor Force (in %) of Equatorial Guinea and Total Labor Force (in %) of Trinidad and Tobago?
Your response must be concise. 22.9. In the year 2010, what is the difference between the Total Labor Force (in %) of Samoa and Total Labor Force (in %) of Trinidad and Tobago?
Make the answer very short. -23.7. In the year 2011, what is the difference between the Total Labor Force (in %) in Colombia and Total Labor Force (in %) in Equatorial Guinea?
Give a very brief answer. -25.2. In the year 2011, what is the difference between the Total Labor Force (in %) in Colombia and Total Labor Force (in %) in Samoa?
Offer a terse response. 22.1. In the year 2011, what is the difference between the Total Labor Force (in %) in Equatorial Guinea and Total Labor Force (in %) in Samoa?
Make the answer very short. 47.3. In the year 2011, what is the difference between the Total Labor Force (in %) of Equatorial Guinea and Total Labor Force (in %) of Trinidad and Tobago?
Your response must be concise. 22.8. In the year 2011, what is the difference between the Total Labor Force (in %) of Samoa and Total Labor Force (in %) of Trinidad and Tobago?
Provide a succinct answer. -24.5. In the year 2012, what is the difference between the Total Labor Force (in %) of Colombia and Total Labor Force (in %) of Equatorial Guinea?
Make the answer very short. -24.9. In the year 2012, what is the difference between the Total Labor Force (in %) in Colombia and Total Labor Force (in %) in Trinidad and Tobago?
Keep it short and to the point. -2.3. In the year 2012, what is the difference between the Total Labor Force (in %) of Equatorial Guinea and Total Labor Force (in %) of Samoa?
Ensure brevity in your answer.  47.1. In the year 2012, what is the difference between the Total Labor Force (in %) in Equatorial Guinea and Total Labor Force (in %) in Trinidad and Tobago?
Provide a short and direct response. 22.6. In the year 2012, what is the difference between the Total Labor Force (in %) of Samoa and Total Labor Force (in %) of Trinidad and Tobago?
Your answer should be compact. -24.5. In the year 2013, what is the difference between the Total Labor Force (in %) of Colombia and Total Labor Force (in %) of Equatorial Guinea?
Provide a short and direct response. -24.5. In the year 2013, what is the difference between the Total Labor Force (in %) in Colombia and Total Labor Force (in %) in Samoa?
Offer a terse response. 22.3. In the year 2013, what is the difference between the Total Labor Force (in %) of Equatorial Guinea and Total Labor Force (in %) of Samoa?
Your answer should be compact. 46.8. In the year 2013, what is the difference between the Total Labor Force (in %) in Samoa and Total Labor Force (in %) in Trinidad and Tobago?
Your response must be concise. -24.3. What is the ratio of the Total Labor Force (in %) of Colombia in 2006 to that in 2007?
Provide a succinct answer. 1.08. What is the ratio of the Total Labor Force (in %) of Samoa in 2006 to that in 2007?
Offer a very short reply. 1.04. What is the ratio of the Total Labor Force (in %) of Trinidad and Tobago in 2006 to that in 2007?
Your answer should be compact. 1.04. What is the ratio of the Total Labor Force (in %) of Colombia in 2006 to that in 2008?
Your answer should be very brief. 1.05. What is the ratio of the Total Labor Force (in %) in Equatorial Guinea in 2006 to that in 2008?
Give a very brief answer. 1. What is the ratio of the Total Labor Force (in %) of Samoa in 2006 to that in 2008?
Your response must be concise. 1.08. What is the ratio of the Total Labor Force (in %) in Trinidad and Tobago in 2006 to that in 2008?
Keep it short and to the point. 1.07. What is the ratio of the Total Labor Force (in %) in Colombia in 2006 to that in 2009?
Offer a very short reply. 1.03. What is the ratio of the Total Labor Force (in %) of Equatorial Guinea in 2006 to that in 2009?
Offer a terse response. 1. What is the ratio of the Total Labor Force (in %) in Samoa in 2006 to that in 2009?
Offer a terse response. 1.12. What is the ratio of the Total Labor Force (in %) in Trinidad and Tobago in 2006 to that in 2009?
Offer a terse response. 1.14. What is the ratio of the Total Labor Force (in %) in Colombia in 2006 to that in 2010?
Ensure brevity in your answer.  1.03. What is the ratio of the Total Labor Force (in %) in Samoa in 2006 to that in 2010?
Your answer should be very brief. 1.16. What is the ratio of the Total Labor Force (in %) in Trinidad and Tobago in 2006 to that in 2010?
Offer a terse response. 1.16. What is the ratio of the Total Labor Force (in %) in Colombia in 2006 to that in 2011?
Provide a succinct answer. 1.02. What is the ratio of the Total Labor Force (in %) of Equatorial Guinea in 2006 to that in 2011?
Keep it short and to the point. 1. What is the ratio of the Total Labor Force (in %) in Samoa in 2006 to that in 2011?
Offer a terse response. 1.2. What is the ratio of the Total Labor Force (in %) of Trinidad and Tobago in 2006 to that in 2011?
Provide a succinct answer. 1.16. What is the ratio of the Total Labor Force (in %) in Colombia in 2006 to that in 2012?
Ensure brevity in your answer.  1.01. What is the ratio of the Total Labor Force (in %) in Samoa in 2006 to that in 2012?
Offer a terse response. 1.19. What is the ratio of the Total Labor Force (in %) of Trinidad and Tobago in 2006 to that in 2012?
Offer a very short reply. 1.15. What is the ratio of the Total Labor Force (in %) in Colombia in 2006 to that in 2013?
Ensure brevity in your answer.  1. What is the ratio of the Total Labor Force (in %) in Samoa in 2006 to that in 2013?
Keep it short and to the point. 1.17. What is the ratio of the Total Labor Force (in %) in Trinidad and Tobago in 2006 to that in 2013?
Offer a terse response. 1.15. What is the ratio of the Total Labor Force (in %) in Colombia in 2007 to that in 2008?
Your response must be concise. 0.97. What is the ratio of the Total Labor Force (in %) of Equatorial Guinea in 2007 to that in 2008?
Keep it short and to the point. 1. What is the ratio of the Total Labor Force (in %) of Samoa in 2007 to that in 2008?
Provide a short and direct response. 1.04. What is the ratio of the Total Labor Force (in %) in Trinidad and Tobago in 2007 to that in 2008?
Offer a terse response. 1.03. What is the ratio of the Total Labor Force (in %) in Colombia in 2007 to that in 2009?
Make the answer very short. 0.96. What is the ratio of the Total Labor Force (in %) of Samoa in 2007 to that in 2009?
Provide a succinct answer. 1.08. What is the ratio of the Total Labor Force (in %) in Trinidad and Tobago in 2007 to that in 2009?
Your answer should be compact. 1.1. What is the ratio of the Total Labor Force (in %) of Colombia in 2007 to that in 2010?
Offer a very short reply. 0.95. What is the ratio of the Total Labor Force (in %) in Equatorial Guinea in 2007 to that in 2010?
Ensure brevity in your answer.  1. What is the ratio of the Total Labor Force (in %) in Samoa in 2007 to that in 2010?
Keep it short and to the point. 1.12. What is the ratio of the Total Labor Force (in %) of Trinidad and Tobago in 2007 to that in 2010?
Your answer should be very brief. 1.11. What is the ratio of the Total Labor Force (in %) in Colombia in 2007 to that in 2011?
Keep it short and to the point. 0.95. What is the ratio of the Total Labor Force (in %) in Equatorial Guinea in 2007 to that in 2011?
Make the answer very short. 1. What is the ratio of the Total Labor Force (in %) of Samoa in 2007 to that in 2011?
Your answer should be compact. 1.16. What is the ratio of the Total Labor Force (in %) of Trinidad and Tobago in 2007 to that in 2011?
Your response must be concise. 1.11. What is the ratio of the Total Labor Force (in %) in Colombia in 2007 to that in 2012?
Give a very brief answer. 0.94. What is the ratio of the Total Labor Force (in %) of Equatorial Guinea in 2007 to that in 2012?
Your answer should be compact. 1. What is the ratio of the Total Labor Force (in %) of Samoa in 2007 to that in 2012?
Ensure brevity in your answer.  1.14. What is the ratio of the Total Labor Force (in %) of Trinidad and Tobago in 2007 to that in 2012?
Make the answer very short. 1.1. What is the ratio of the Total Labor Force (in %) of Colombia in 2007 to that in 2013?
Your answer should be compact. 0.93. What is the ratio of the Total Labor Force (in %) in Samoa in 2007 to that in 2013?
Give a very brief answer. 1.12. What is the ratio of the Total Labor Force (in %) in Trinidad and Tobago in 2007 to that in 2013?
Your answer should be compact. 1.1. What is the ratio of the Total Labor Force (in %) of Colombia in 2008 to that in 2009?
Provide a succinct answer. 0.99. What is the ratio of the Total Labor Force (in %) of Equatorial Guinea in 2008 to that in 2009?
Provide a succinct answer. 1. What is the ratio of the Total Labor Force (in %) in Samoa in 2008 to that in 2009?
Offer a terse response. 1.04. What is the ratio of the Total Labor Force (in %) of Trinidad and Tobago in 2008 to that in 2009?
Offer a terse response. 1.07. What is the ratio of the Total Labor Force (in %) in Colombia in 2008 to that in 2010?
Ensure brevity in your answer.  0.98. What is the ratio of the Total Labor Force (in %) in Samoa in 2008 to that in 2010?
Give a very brief answer. 1.08. What is the ratio of the Total Labor Force (in %) of Trinidad and Tobago in 2008 to that in 2010?
Offer a very short reply. 1.08. What is the ratio of the Total Labor Force (in %) of Colombia in 2008 to that in 2011?
Ensure brevity in your answer.  0.97. What is the ratio of the Total Labor Force (in %) of Samoa in 2008 to that in 2011?
Your response must be concise. 1.11. What is the ratio of the Total Labor Force (in %) of Trinidad and Tobago in 2008 to that in 2011?
Give a very brief answer. 1.08. What is the ratio of the Total Labor Force (in %) in Colombia in 2008 to that in 2012?
Provide a succinct answer. 0.97. What is the ratio of the Total Labor Force (in %) in Samoa in 2008 to that in 2012?
Make the answer very short. 1.1. What is the ratio of the Total Labor Force (in %) in Trinidad and Tobago in 2008 to that in 2012?
Offer a very short reply. 1.07. What is the ratio of the Total Labor Force (in %) in Colombia in 2008 to that in 2013?
Give a very brief answer. 0.96. What is the ratio of the Total Labor Force (in %) of Equatorial Guinea in 2008 to that in 2013?
Keep it short and to the point. 1. What is the ratio of the Total Labor Force (in %) of Samoa in 2008 to that in 2013?
Your answer should be compact. 1.08. What is the ratio of the Total Labor Force (in %) of Trinidad and Tobago in 2008 to that in 2013?
Provide a short and direct response. 1.07. What is the ratio of the Total Labor Force (in %) of Equatorial Guinea in 2009 to that in 2010?
Ensure brevity in your answer.  1. What is the ratio of the Total Labor Force (in %) in Samoa in 2009 to that in 2010?
Your answer should be very brief. 1.03. What is the ratio of the Total Labor Force (in %) in Trinidad and Tobago in 2009 to that in 2010?
Give a very brief answer. 1.01. What is the ratio of the Total Labor Force (in %) in Colombia in 2009 to that in 2011?
Give a very brief answer. 0.99. What is the ratio of the Total Labor Force (in %) in Samoa in 2009 to that in 2011?
Your response must be concise. 1.07. What is the ratio of the Total Labor Force (in %) of Trinidad and Tobago in 2009 to that in 2011?
Your answer should be compact. 1.01. What is the ratio of the Total Labor Force (in %) of Colombia in 2009 to that in 2012?
Provide a succinct answer. 0.98. What is the ratio of the Total Labor Force (in %) in Equatorial Guinea in 2009 to that in 2012?
Offer a terse response. 1. What is the ratio of the Total Labor Force (in %) in Samoa in 2009 to that in 2012?
Give a very brief answer. 1.06. What is the ratio of the Total Labor Force (in %) of Trinidad and Tobago in 2009 to that in 2012?
Offer a very short reply. 1. What is the ratio of the Total Labor Force (in %) in Colombia in 2009 to that in 2013?
Make the answer very short. 0.97. What is the ratio of the Total Labor Force (in %) in Equatorial Guinea in 2009 to that in 2013?
Offer a terse response. 1. What is the ratio of the Total Labor Force (in %) in Samoa in 2009 to that in 2013?
Provide a succinct answer. 1.04. What is the ratio of the Total Labor Force (in %) in Trinidad and Tobago in 2009 to that in 2013?
Keep it short and to the point. 1. What is the ratio of the Total Labor Force (in %) in Colombia in 2010 to that in 2011?
Provide a succinct answer. 0.99. What is the ratio of the Total Labor Force (in %) of Samoa in 2010 to that in 2011?
Keep it short and to the point. 1.04. What is the ratio of the Total Labor Force (in %) of Colombia in 2010 to that in 2012?
Give a very brief answer. 0.98. What is the ratio of the Total Labor Force (in %) in Equatorial Guinea in 2010 to that in 2012?
Give a very brief answer. 1. What is the ratio of the Total Labor Force (in %) in Samoa in 2010 to that in 2012?
Give a very brief answer. 1.02. What is the ratio of the Total Labor Force (in %) in Trinidad and Tobago in 2010 to that in 2012?
Give a very brief answer. 0.99. What is the ratio of the Total Labor Force (in %) of Colombia in 2010 to that in 2013?
Offer a very short reply. 0.97. What is the ratio of the Total Labor Force (in %) in Trinidad and Tobago in 2010 to that in 2013?
Give a very brief answer. 0.99. What is the ratio of the Total Labor Force (in %) of Equatorial Guinea in 2011 to that in 2012?
Keep it short and to the point. 1. What is the ratio of the Total Labor Force (in %) of Samoa in 2011 to that in 2012?
Make the answer very short. 0.99. What is the ratio of the Total Labor Force (in %) in Trinidad and Tobago in 2011 to that in 2012?
Your response must be concise. 1. What is the ratio of the Total Labor Force (in %) of Colombia in 2011 to that in 2013?
Provide a succinct answer. 0.98. What is the ratio of the Total Labor Force (in %) of Equatorial Guinea in 2011 to that in 2013?
Give a very brief answer. 1. What is the ratio of the Total Labor Force (in %) of Samoa in 2011 to that in 2013?
Give a very brief answer. 0.97. What is the ratio of the Total Labor Force (in %) in Colombia in 2012 to that in 2013?
Give a very brief answer. 0.99. What is the ratio of the Total Labor Force (in %) of Samoa in 2012 to that in 2013?
Make the answer very short. 0.98. What is the ratio of the Total Labor Force (in %) in Trinidad and Tobago in 2012 to that in 2013?
Your response must be concise. 1. What is the difference between the highest and the second highest Total Labor Force (in %) in Samoa?
Offer a terse response. 0.8. What is the difference between the highest and the lowest Total Labor Force (in %) in Colombia?
Keep it short and to the point. 2.8. What is the difference between the highest and the lowest Total Labor Force (in %) in Equatorial Guinea?
Give a very brief answer. 0.3. 